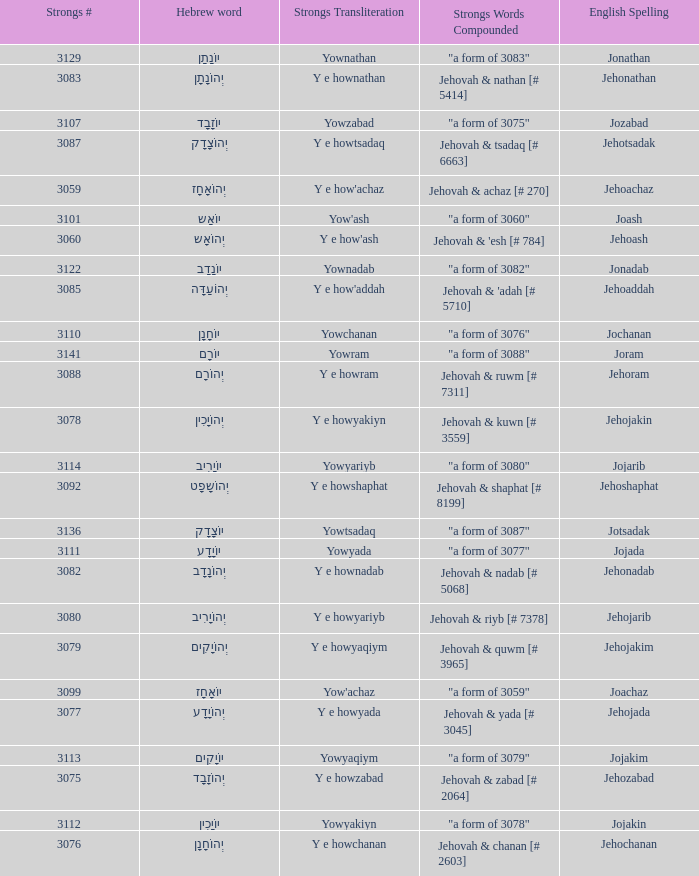How many strongs transliteration of the english spelling of the work jehojakin? 1.0. 